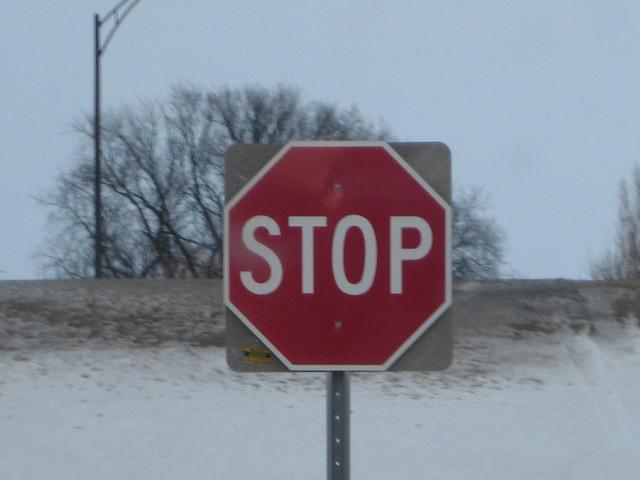How many letters are on the stop sign?
Give a very brief answer. 4. How many sheep are there?
Give a very brief answer. 0. 